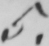What is written in this line of handwriting? 5 . 